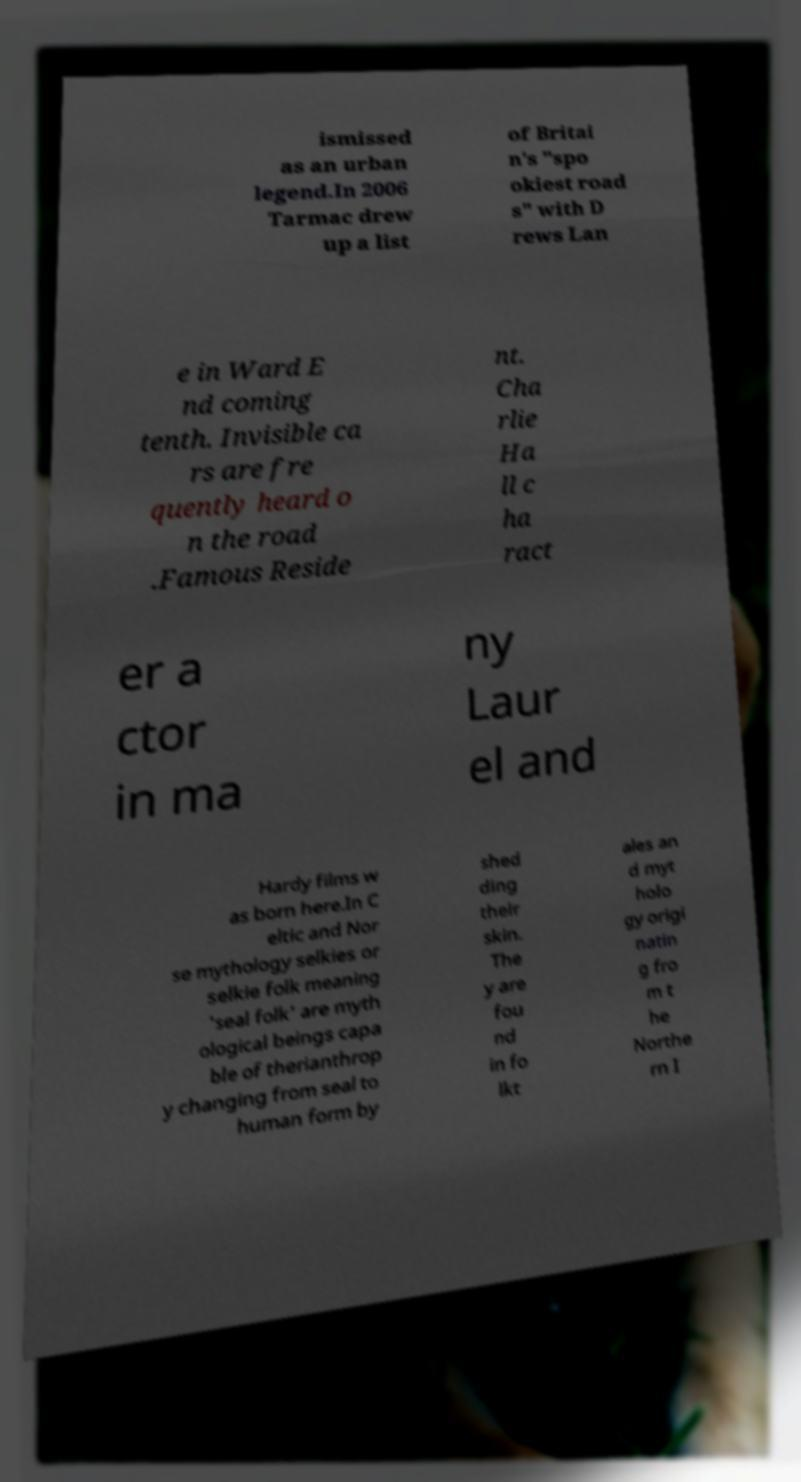Can you read and provide the text displayed in the image?This photo seems to have some interesting text. Can you extract and type it out for me? ismissed as an urban legend.In 2006 Tarmac drew up a list of Britai n's "spo okiest road s" with D rews Lan e in Ward E nd coming tenth. Invisible ca rs are fre quently heard o n the road .Famous Reside nt. Cha rlie Ha ll c ha ract er a ctor in ma ny Laur el and Hardy films w as born here.In C eltic and Nor se mythology selkies or selkie folk meaning 'seal folk' are myth ological beings capa ble of therianthrop y changing from seal to human form by shed ding their skin. The y are fou nd in fo lkt ales an d myt holo gy origi natin g fro m t he Northe rn I 